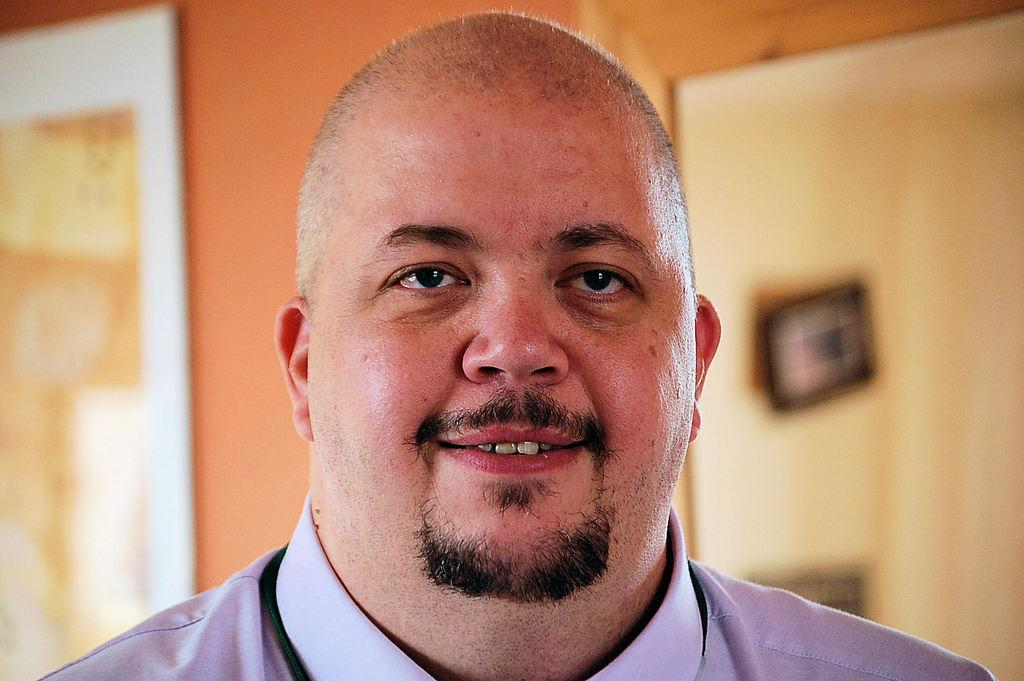Who is the main subject in the foreground of the image? There is a man in the foreground of the image. What can be seen in the background of the image? There is a wall in the background of the image. What is located on the left side of the image? There is a board on the left side of the image. How would you describe the background's appearance? The background appears blurry. How many houses are visible on the island in the image? There is no island or houses present in the image. What type of coat is the man wearing in the image? The image does not show the man wearing a coat, so it cannot be determined from the image. 